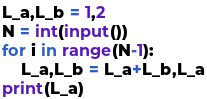<code> <loc_0><loc_0><loc_500><loc_500><_Python_>L_a,L_b = 1,2
N = int(input())
for i in range(N-1):
    L_a,L_b = L_a+L_b,L_a
print(L_a)</code> 